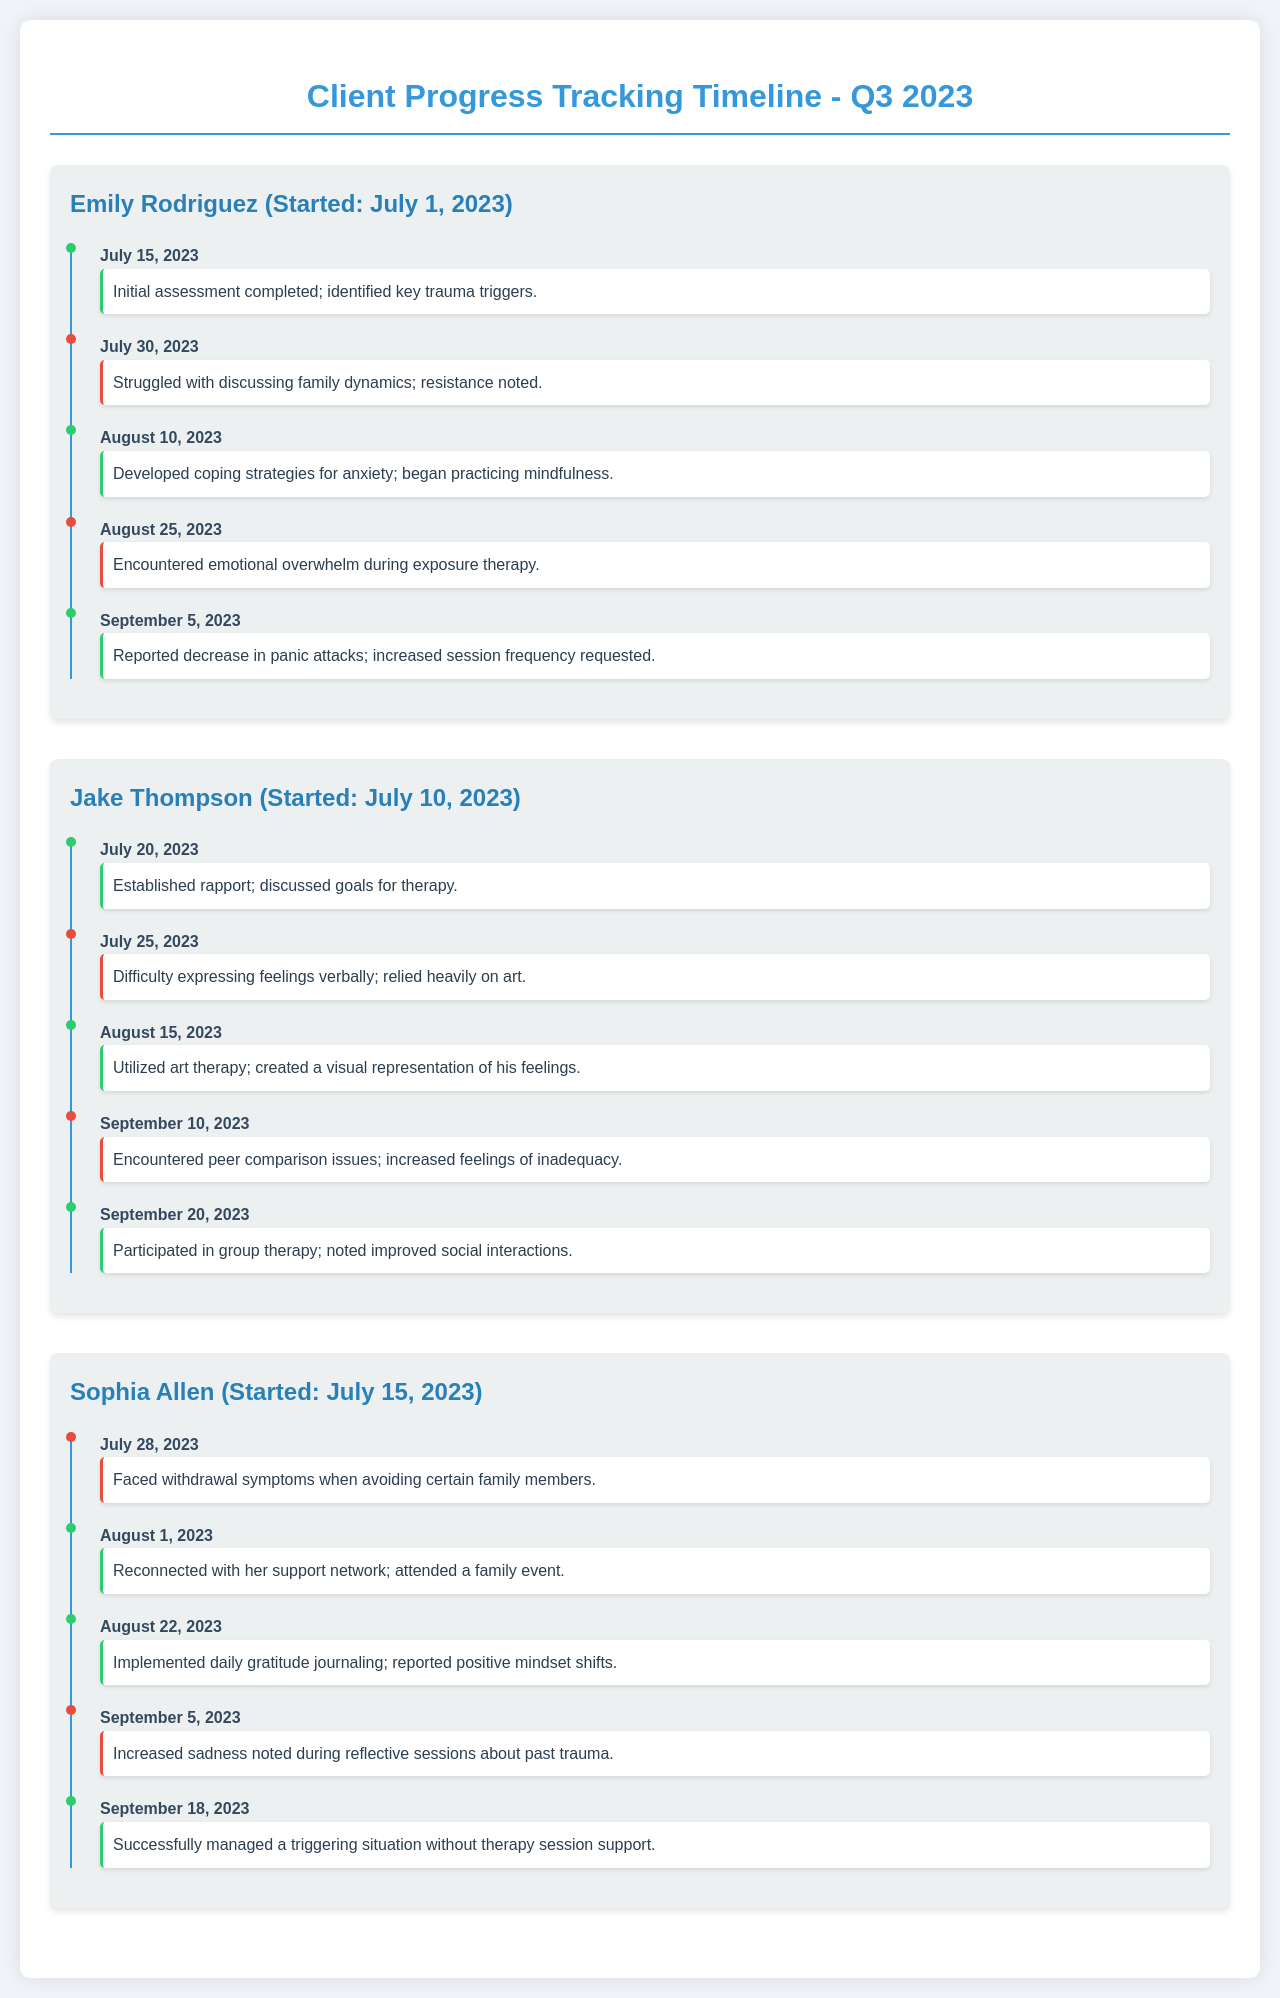What is the name of the first client? The first client's name is clearly listed as Emily Rodriguez in the document's section for clients.
Answer: Emily Rodriguez When did Jake Thompson start therapy? The document provides the start date of Jake Thompson's therapy at the beginning of his section.
Answer: July 10, 2023 What coping strategies did Emily develop? The document notes that Emily developed coping strategies, specifically mentioning anxiety and mindfulness in her milestone achievements.
Answer: Coping strategies for anxiety; mindfulness What challenge did Sophia face on July 28, 2023? The specific challenge listed for Sophia on that date provides insight into her experience as recorded in the document.
Answer: Withdrawal symptoms How many milestones did Jake Thompson achieve? Counting the milestones listed in Jake's timeline section will yield the total number he achieved.
Answer: Three What emotional issue did Sophia report on September 5, 2023? The document details increased sadness in her reflective sessions as the emotional issue she reported.
Answer: Increased sadness What event helped Sophia reconnect with her support network? The document provides information about a specific family event that contributed to Sophia’s reconnection efforts.
Answer: Attended a family event On which date did Emily request an increase in session frequency? The exact date when Emily requested to increase her sessions is mentioned in her events list.
Answer: September 5, 2023 Which therapy method did Jake use to express his feelings? The document discusses the specific modality of therapy that Jake turned to for expressing his emotions.
Answer: Art therapy 